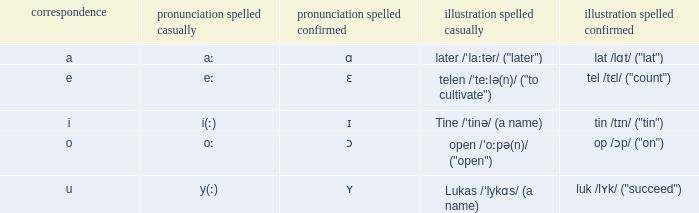What is Pronunciation Spelled Free, when Pronunciation Spelled Checked is "ɑ"? Aː. 